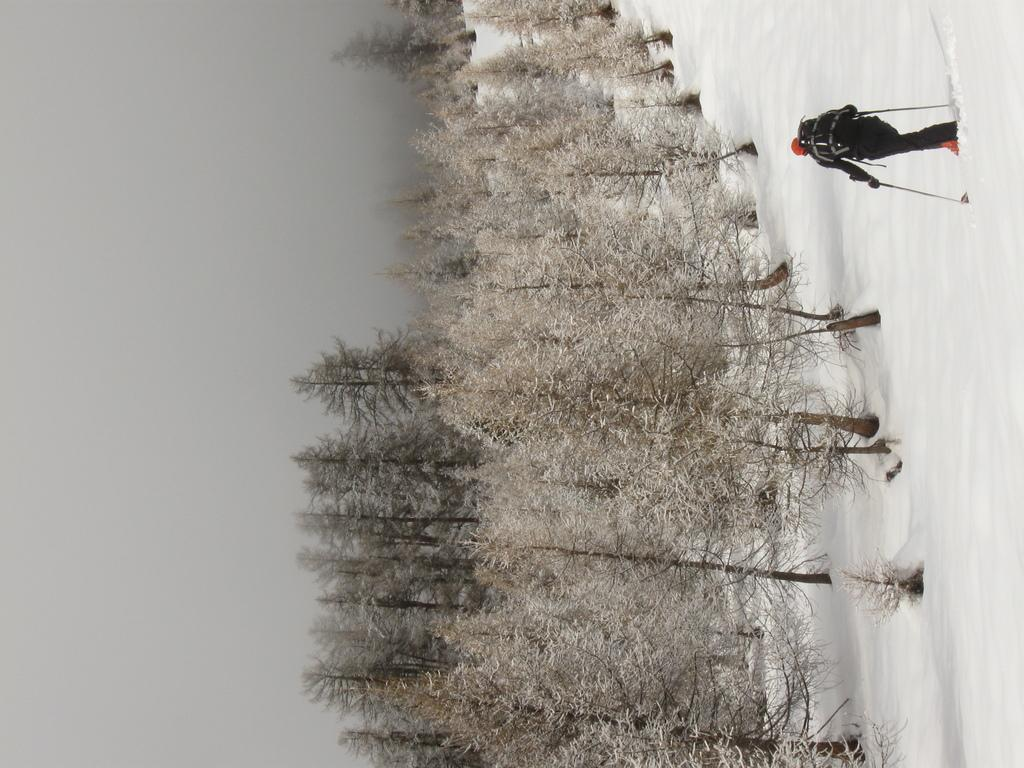What type of vegetation can be seen in the image? There are trees in the image. What activity is the human in the image engaged in? The human is skiing in the snow. How would you describe the weather based on the image? The sky is cloudy in the image. Where is the pail located in the image? There is no pail present in the image. What type of machine is being used by the skier in the image? The image does not show any machines being used by the skier; they are using skis. 